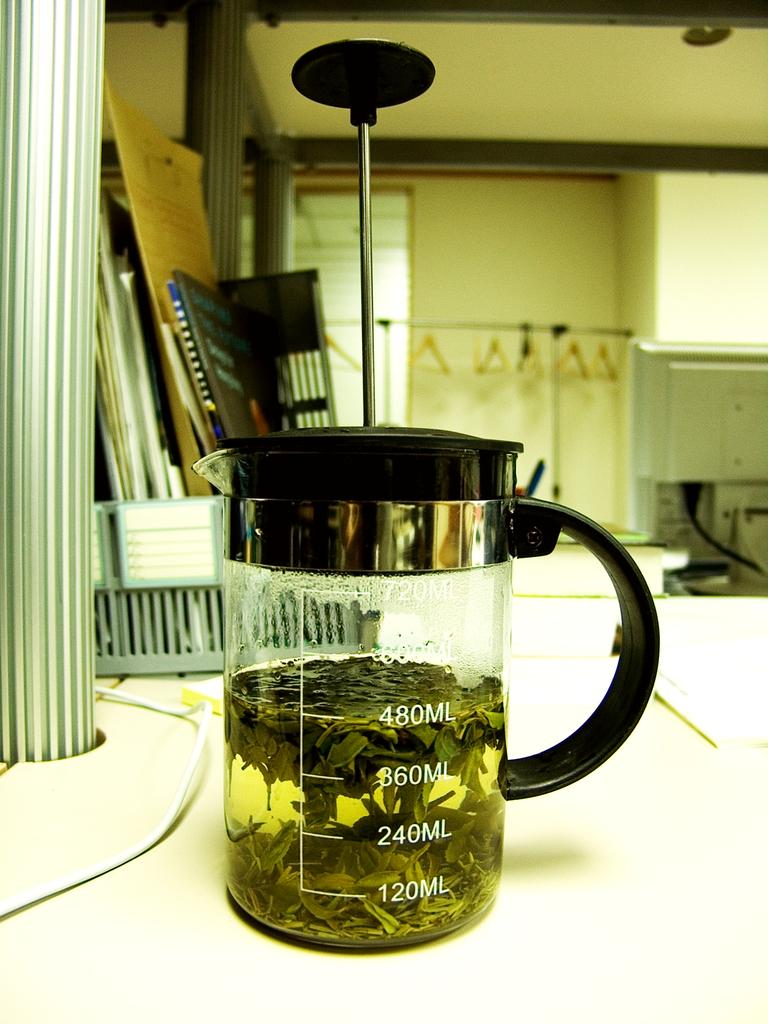<image>
Share a concise interpretation of the image provided. A glass measuring cup is filled to 480 ml. 